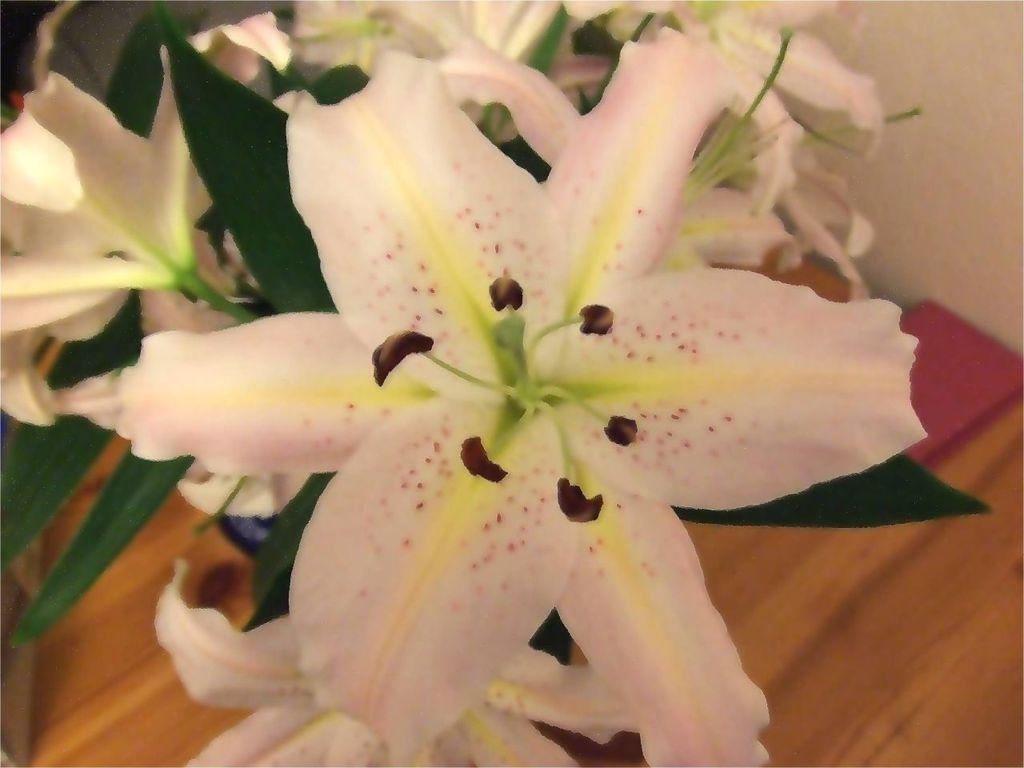What type of flowers are in the image? There are white colored flowers in the image. What else can be seen on the flowers besides the petals? The flowers have leaves. Where are the flowers and leaves located? The flowers and leaves are on a table. How many oranges are on the table next to the flowers? There is no mention of oranges in the image, so we cannot determine how many there are. 